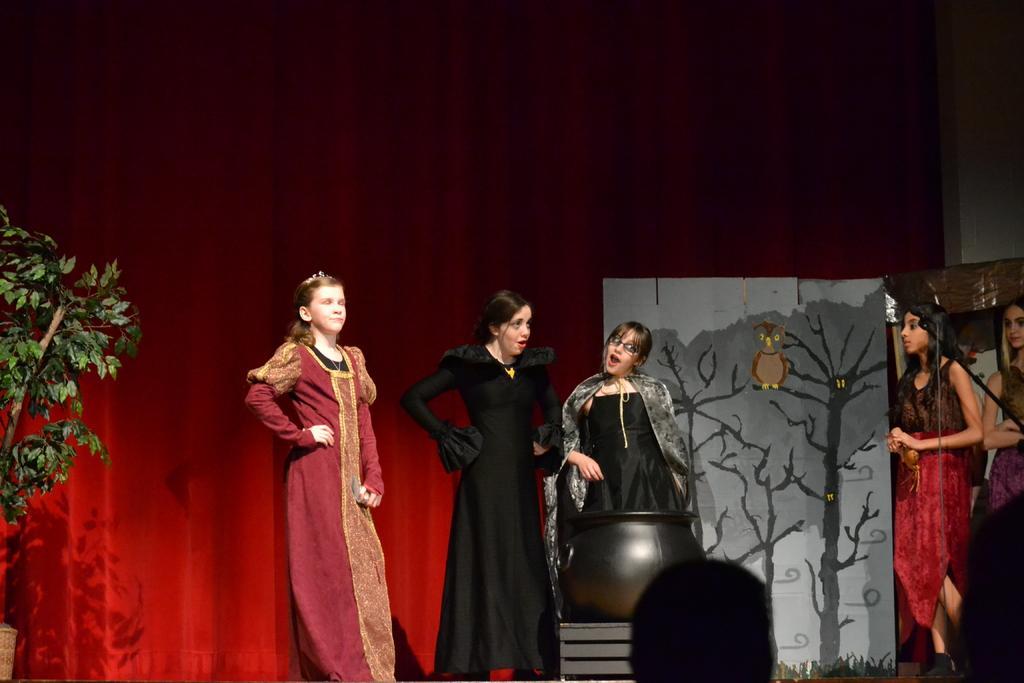Could you give a brief overview of what you see in this image? In this image I can see few persons wearing black colored dress and few persons wearing black and red colored dress are standing. I can see a black colored bowl, the red colored curtain, a tree and a huge board. I can see the cream colored wall. 